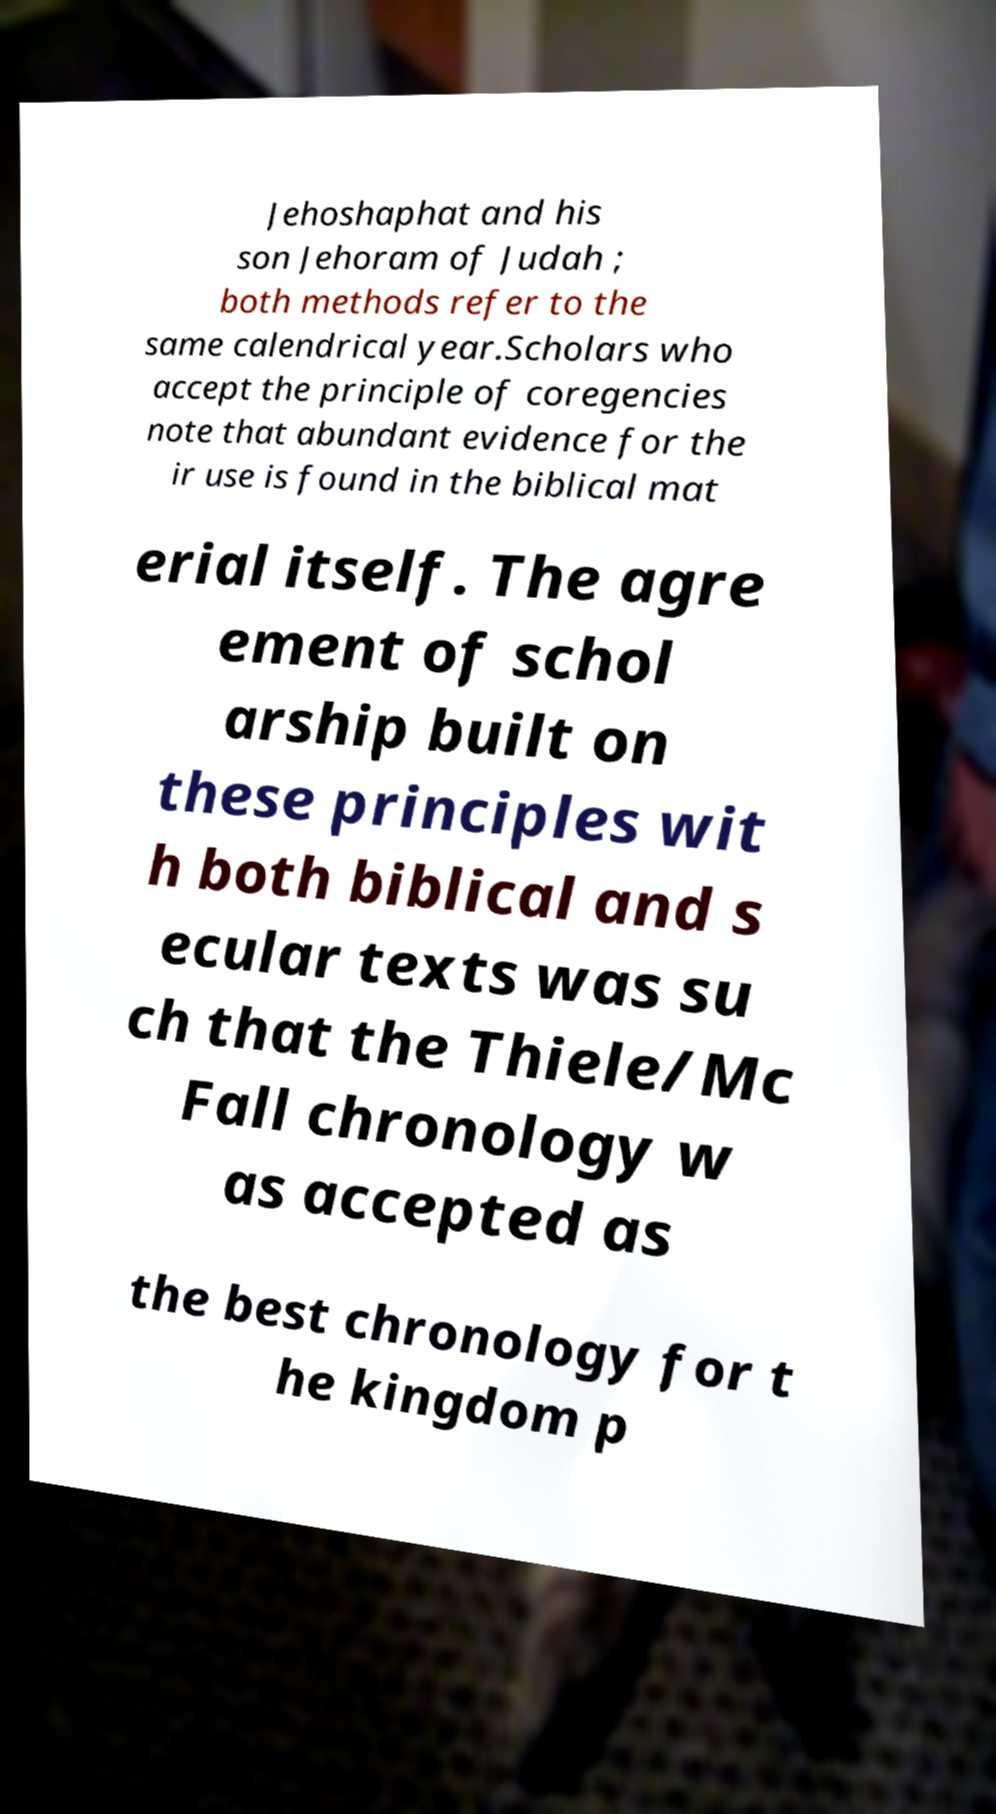What messages or text are displayed in this image? I need them in a readable, typed format. Jehoshaphat and his son Jehoram of Judah ; both methods refer to the same calendrical year.Scholars who accept the principle of coregencies note that abundant evidence for the ir use is found in the biblical mat erial itself. The agre ement of schol arship built on these principles wit h both biblical and s ecular texts was su ch that the Thiele/Mc Fall chronology w as accepted as the best chronology for t he kingdom p 